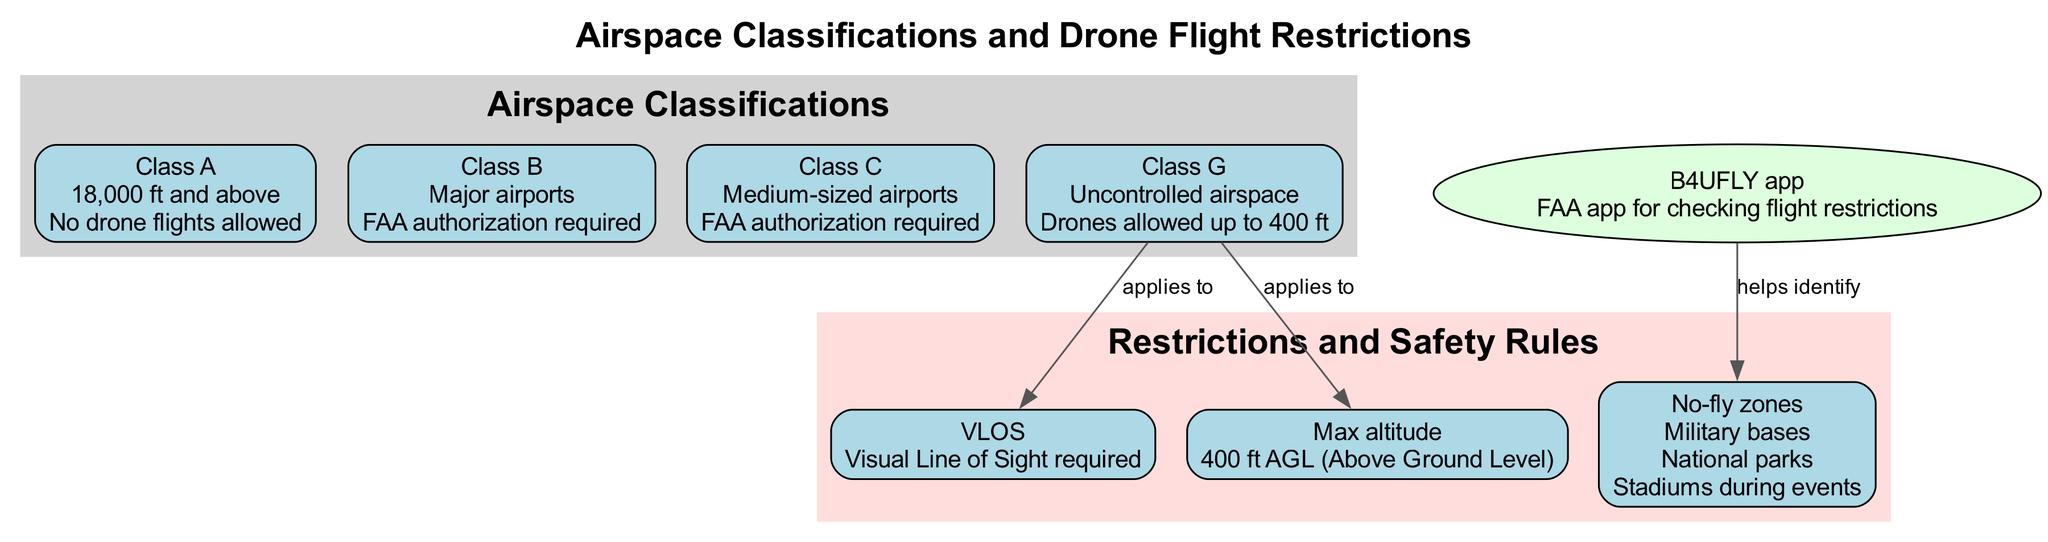What is the maximum altitude for drone flights? The diagram states that the maximum altitude for drone flights is specified as 400 ft AGL (Above Ground Level) under safety rules.
Answer: 400 ft AGL In which airspace class are drone flights not allowed? The diagram indicates that in Class A airspace, drone flights are not permitted according to the restriction described.
Answer: Class A How many airspace types are identified in the diagram? Upon reviewing the diagram, there are four airspace classifications: Class A, Class B, Class C, and Class G, which can be counted directly from the nodes.
Answer: 4 What type of app is the B4UFLY app? The diagram describes the B4UFLY app as an FAA app for checking flight restrictions, indicating its role in regard to airspace and drone safety.
Answer: FAA app Which airspace class requires FAA authorization? The diagram specifies that both Class B and Class C require FAA authorization for drone flights, thus indicating these two classes as the answer.
Answer: Class B, Class C What is required for drone operation in Class G airspace? The diagram specifies that in Class G airspace, the requirements include maintaining Visual Line of Sight (VLOS) and adhering to the maximum altitude of 400 ft AGL.
Answer: VLOS, 400 ft AGL List an example of a no-fly zone. The diagram provides examples under the no-fly zones category, including military bases, national parks, and stadiums during events—as listed.
Answer: Military bases How does the B4UFLY app help drone pilots? The diagram illustrates that the B4UFLY app helps identify no-fly zones, making it a resource for drone pilots to ensure they do not fly in restricted areas.
Answer: Helps identify no-fly zones What is the main purpose of visual line of sight (VLOS) as mentioned in the diagram? The diagram labels VLOS under safety rules, indicating that it is a required practice for safe drone operation, ensuring the pilot maintains visual contact with the drone.
Answer: Required for safe operation 